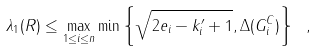Convert formula to latex. <formula><loc_0><loc_0><loc_500><loc_500>\lambda _ { 1 } ( R ) \leq \max _ { 1 \leq i \leq n } \min \left \{ \sqrt { 2 e _ { i } - k ^ { \prime } _ { i } + 1 } , \Delta ( G _ { i } ^ { C } ) \right \} \ ,</formula> 